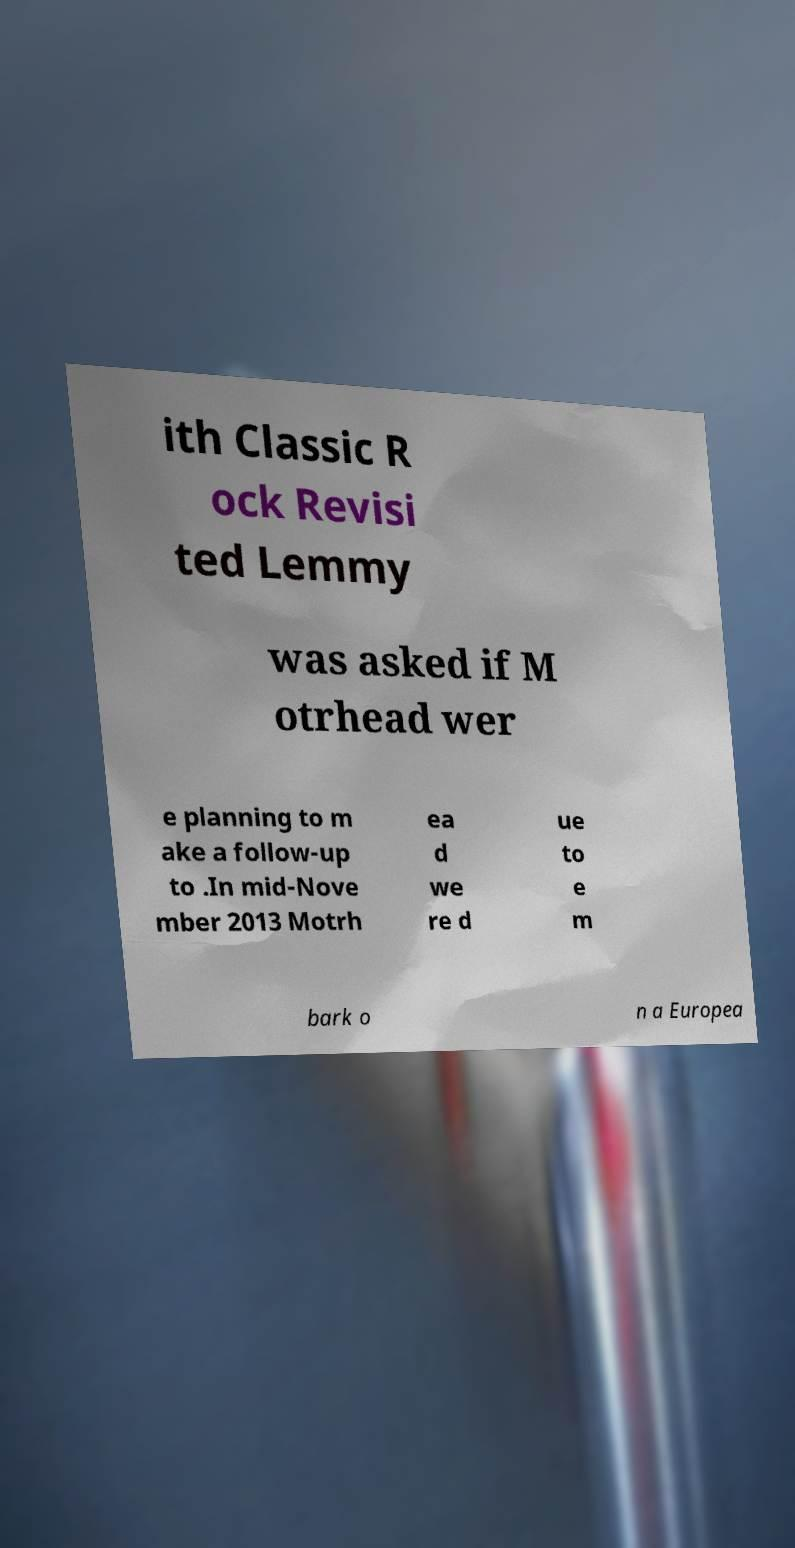I need the written content from this picture converted into text. Can you do that? ith Classic R ock Revisi ted Lemmy was asked if M otrhead wer e planning to m ake a follow-up to .In mid-Nove mber 2013 Motrh ea d we re d ue to e m bark o n a Europea 